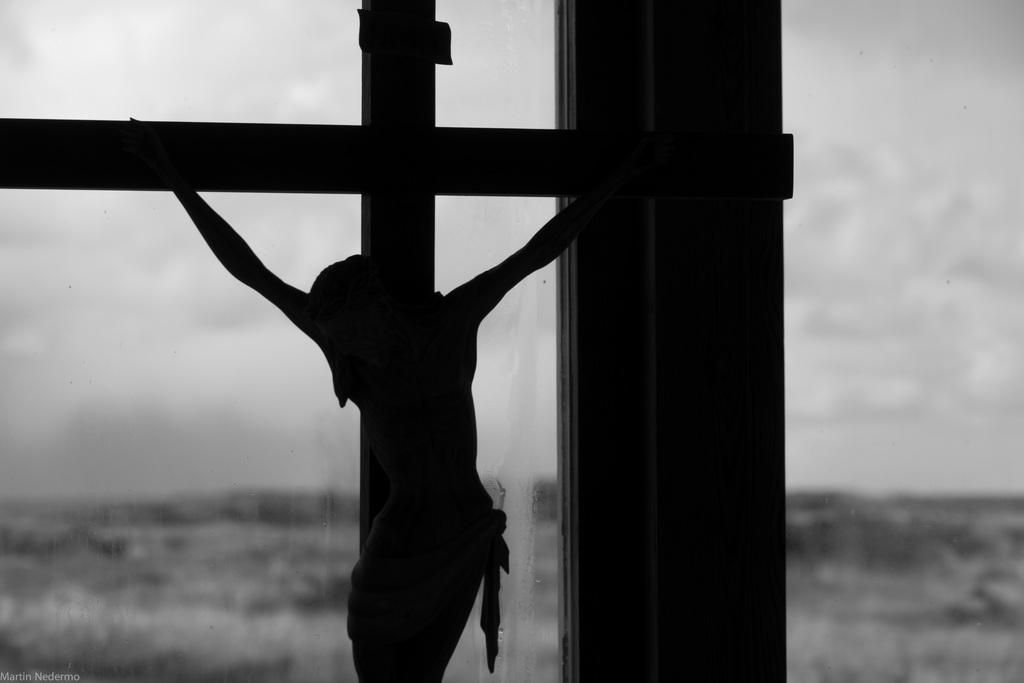What is the main subject of the image? The main subject of the image is a statue of Jesus Christ. How is the statue positioned in the image? The statue is hanged to the cross. Where is the statue placed in relation to the viewer? The statue is kept in front. What can be seen in the background of the image? There is a window in the image. What is the color scheme of the image? The image is in black and white color. What type of development can be seen happening in the image? There is no development or construction activity visible in the image; it features a statue of Jesus Christ. How many hens are present in the image? There are no hens present in the image. 